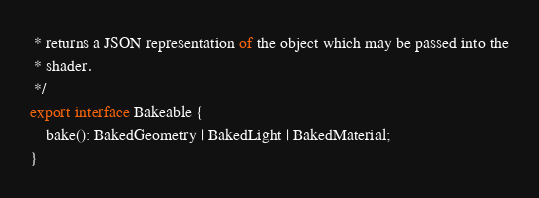<code> <loc_0><loc_0><loc_500><loc_500><_TypeScript_> * returns a JSON representation of the object which may be passed into the
 * shader.
 */
export interface Bakeable {
    bake(): BakedGeometry | BakedLight | BakedMaterial;
}
</code> 